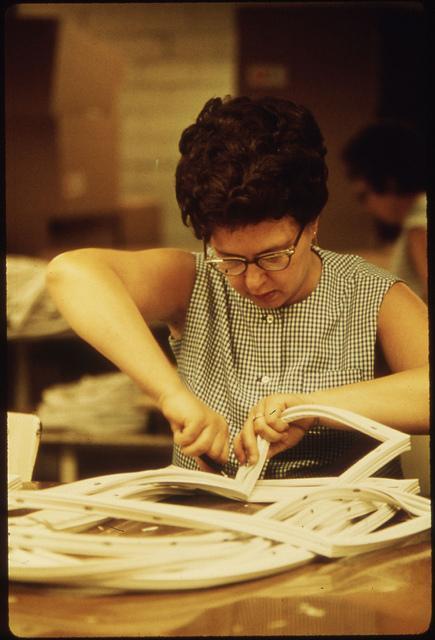How many people are there?
Give a very brief answer. 2. 